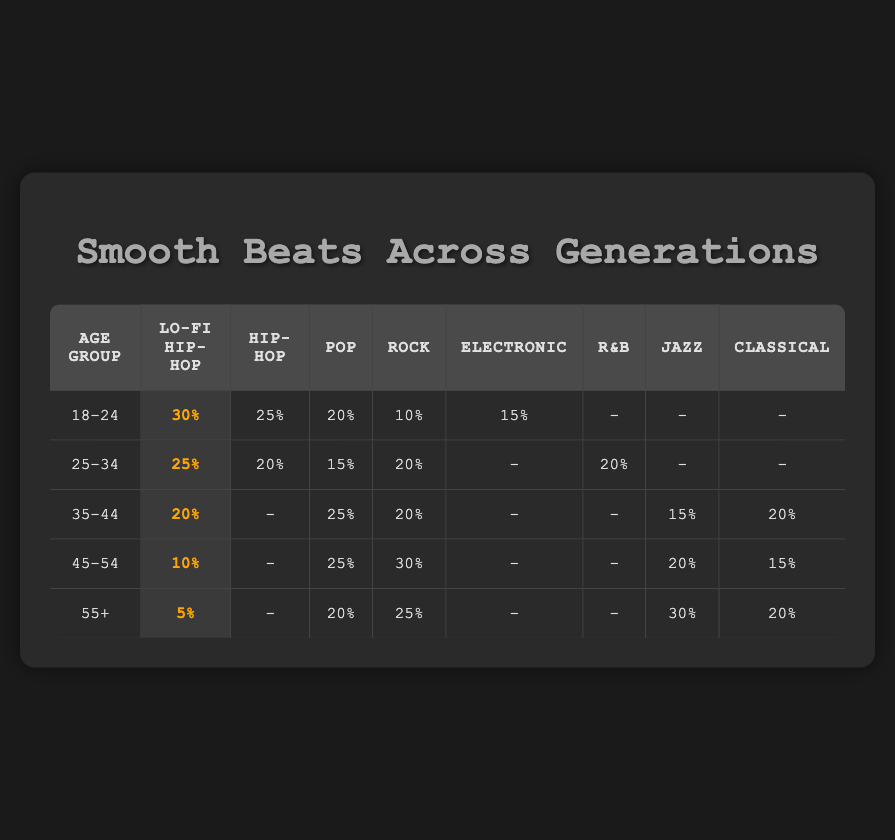What age group has the highest preference for Lo-fi Hip-Hop? Referring to the table, the age group 18-24 has the highest percentage of preference for Lo-fi Hip-Hop at 30%.
Answer: 18-24 What is the total percentage of preference for Pop across all age groups? Summing the Pop preferences from each age group: 20 + 15 + 25 + 25 + 20 = 105%.
Answer: 105% Is Hip-Hop more popular than Lo-fi Hip-Hop in the 25-34 age group? In the 25-34 age group, Hip-Hop has a preference of 20%, while Lo-fi Hip-Hop has a preference of 25%. Thus, Hip-Hop is not more popular.
Answer: No How does the preference for Classical music compare between the 35-44 and 55+ age groups? The 35-44 age group shows a preference of 20% for Classical music, while the 55+ age group also shows a preference of 20%. Therefore, they are equal.
Answer: They are equal What age group shows the widest gap between the preference for Rock and Lo-fi Hip-Hop? The age group 45-54 shows Rock at 30% and Lo-fi Hip-Hop at 10%, creating a gap of 20%. Checking other groups shows no larger gap.
Answer: 45-54 